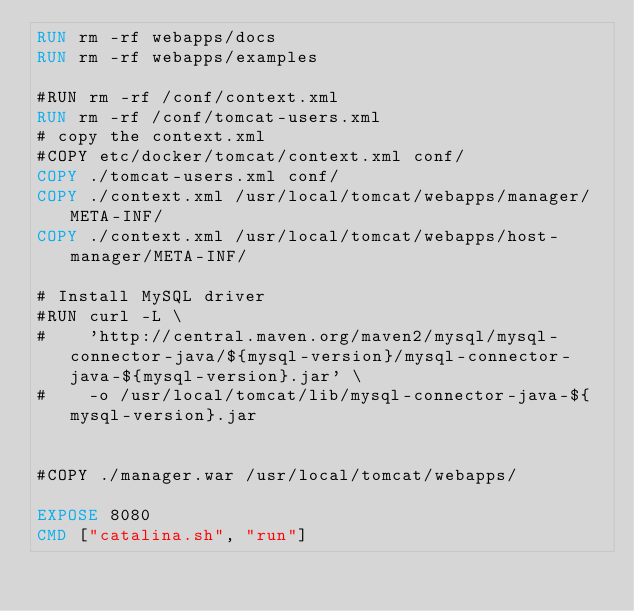<code> <loc_0><loc_0><loc_500><loc_500><_Dockerfile_>RUN rm -rf webapps/docs
RUN rm -rf webapps/examples

#RUN rm -rf /conf/context.xml
RUN rm -rf /conf/tomcat-users.xml
# copy the context.xml
#COPY etc/docker/tomcat/context.xml conf/
COPY ./tomcat-users.xml conf/
COPY ./context.xml /usr/local/tomcat/webapps/manager/META-INF/
COPY ./context.xml /usr/local/tomcat/webapps/host-manager/META-INF/

# Install MySQL driver
#RUN curl -L \
#    'http://central.maven.org/maven2/mysql/mysql-connector-java/${mysql-version}/mysql-connector-java-${mysql-version}.jar' \
#    -o /usr/local/tomcat/lib/mysql-connector-java-${mysql-version}.jar


#COPY ./manager.war /usr/local/tomcat/webapps/

EXPOSE 8080
CMD ["catalina.sh", "run"]
</code> 